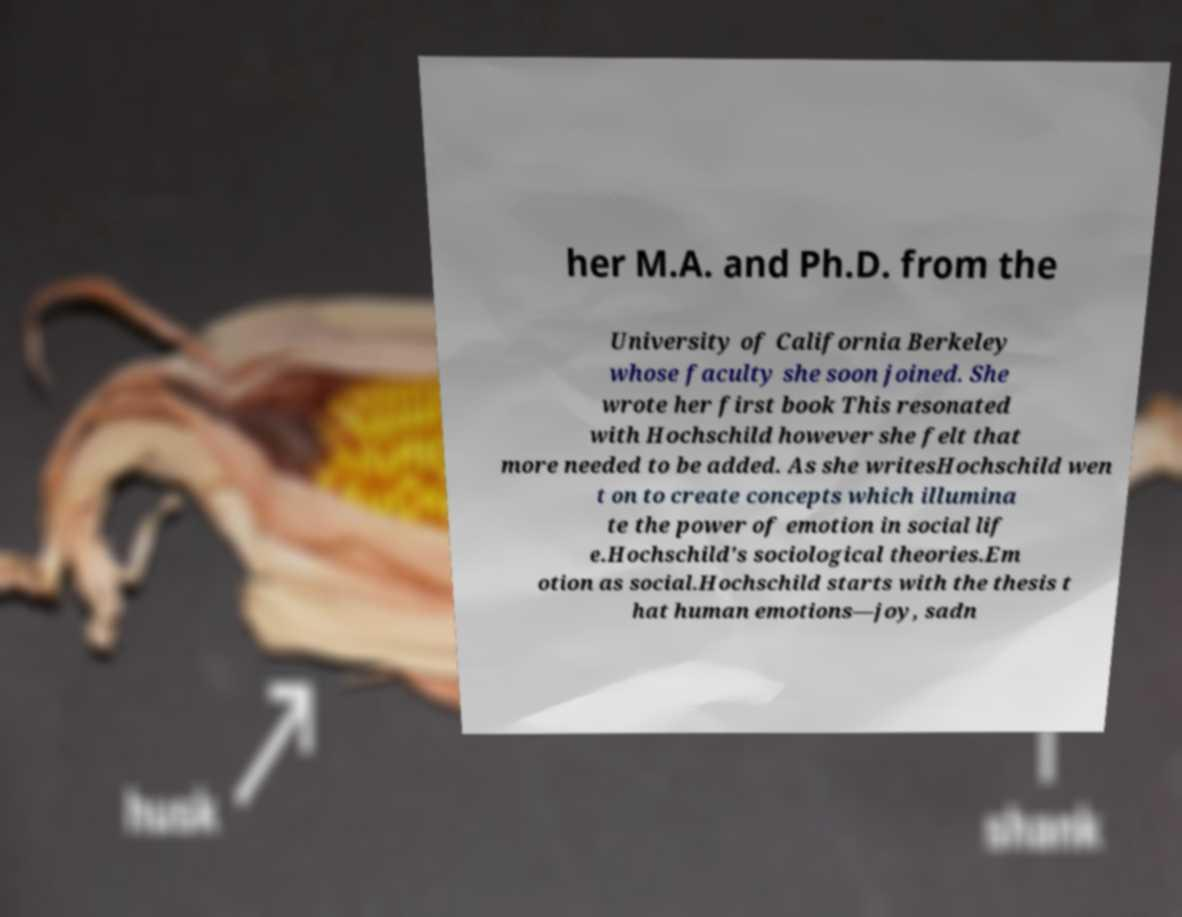Could you assist in decoding the text presented in this image and type it out clearly? her M.A. and Ph.D. from the University of California Berkeley whose faculty she soon joined. She wrote her first book This resonated with Hochschild however she felt that more needed to be added. As she writesHochschild wen t on to create concepts which illumina te the power of emotion in social lif e.Hochschild's sociological theories.Em otion as social.Hochschild starts with the thesis t hat human emotions—joy, sadn 